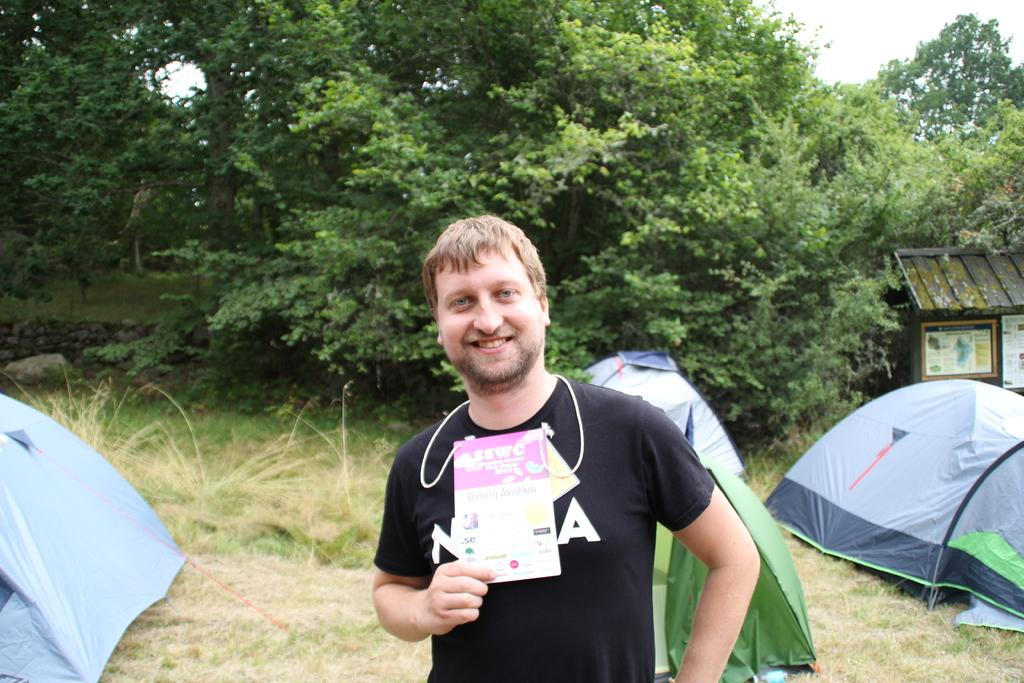What is the person in the image doing? The person is standing in the image. What is the person holding in the image? The person is holding a card. What color is the shirt the person is wearing? The person is wearing a black shirt. What can be seen in the background of the image? There are tents and trees with green color in the background. What is the color of the sky in the image? The sky is white in color. Can you see any icicles hanging from the trees in the image? There are no icicles visible in the image; the trees have green leaves, and the sky is white, indicating a warm or sunny day. 